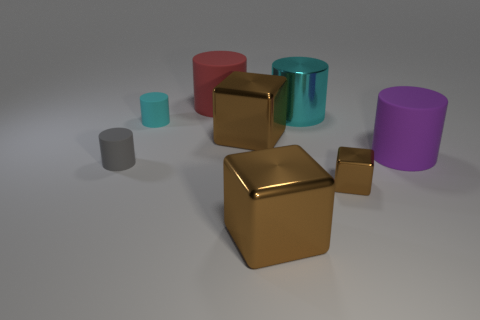Subtract all gray cylinders. How many cylinders are left? 4 Subtract all gray cylinders. How many cylinders are left? 4 Subtract all green cylinders. Subtract all yellow cubes. How many cylinders are left? 5 Add 1 small metal blocks. How many objects exist? 9 Subtract all blocks. How many objects are left? 5 Subtract all cyan rubber spheres. Subtract all purple rubber objects. How many objects are left? 7 Add 4 big cyan shiny cylinders. How many big cyan shiny cylinders are left? 5 Add 7 cyan cylinders. How many cyan cylinders exist? 9 Subtract 1 brown cubes. How many objects are left? 7 